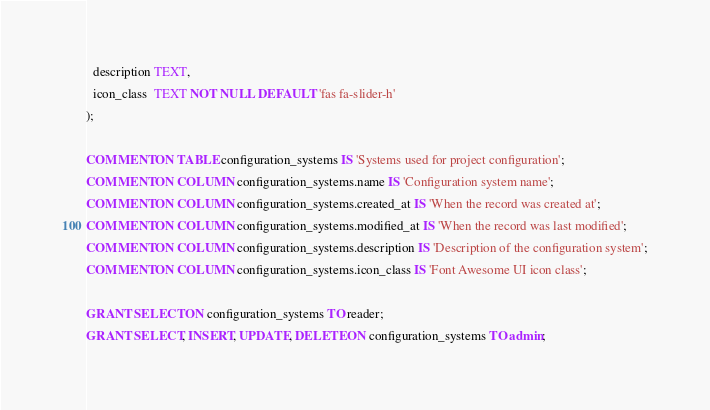Convert code to text. <code><loc_0><loc_0><loc_500><loc_500><_SQL_>  description TEXT,
  icon_class  TEXT NOT NULL DEFAULT 'fas fa-slider-h'
);

COMMENT ON TABLE configuration_systems IS 'Systems used for project configuration';
COMMENT ON COLUMN configuration_systems.name IS 'Configuration system name';
COMMENT ON COLUMN configuration_systems.created_at IS 'When the record was created at';
COMMENT ON COLUMN configuration_systems.modified_at IS 'When the record was last modified';
COMMENT ON COLUMN configuration_systems.description IS 'Description of the configuration system';
COMMENT ON COLUMN configuration_systems.icon_class IS 'Font Awesome UI icon class';

GRANT SELECT ON configuration_systems TO reader;
GRANT SELECT, INSERT, UPDATE, DELETE ON configuration_systems TO admin;
</code> 